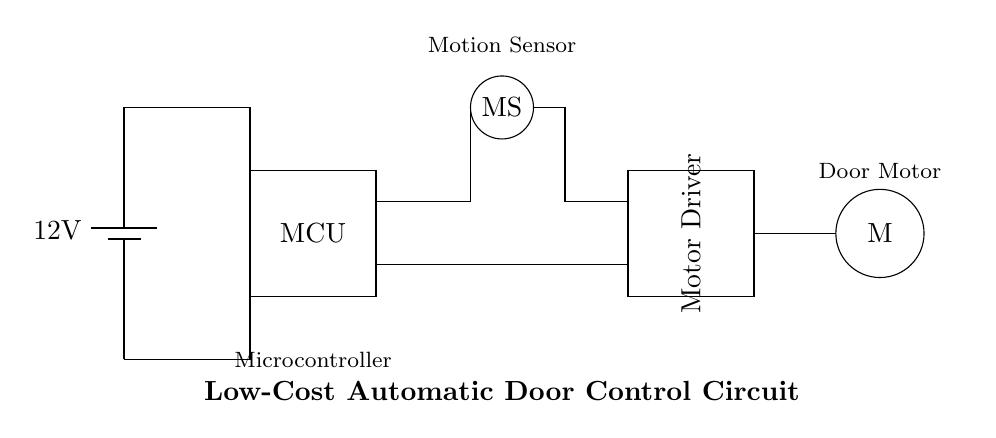What is the voltage of the power supply? The diagram shows a battery labeled with a voltage of 12 volts, which serves as the power supply for the circuit.
Answer: 12 volts What does MCU stand for in this circuit? The label in the rectangle indicates that the component is a Microcontroller Unit, which is a common component used for processing and controlling functions in an electronic circuit.
Answer: Microcontroller How many main components are present in the circuit? There are four main components in the circuit diagram: the power supply, microcontroller, motor driver, and door motor.
Answer: Four What is the purpose of the motion sensor? The motion sensor is indicated in the diagram, and its function is to detect motion in the hospital corridor to control the opening of the automatic doors.
Answer: Detect motion What is the connection type between the microcontroller and the motor driver? The microcontroller is connected to the motor driver through a direct wire, which allows the microcontroller to send control signals to the motor driver to actuate the door motor.
Answer: Direct wire connection What is the main output device in this circuit? The diagram shows a door motor as a circular component, which is the main output device responsible for physically moving the doors open or closed when activated by the control signals.
Answer: Door motor What function does the motor driver serve in this circuit? The motor driver, labeled in the circuit, is responsible for controlling the power supplied to the door motor based on the signals received from the microcontroller, enabling the motor to operate effectively.
Answer: Control power to the motor 